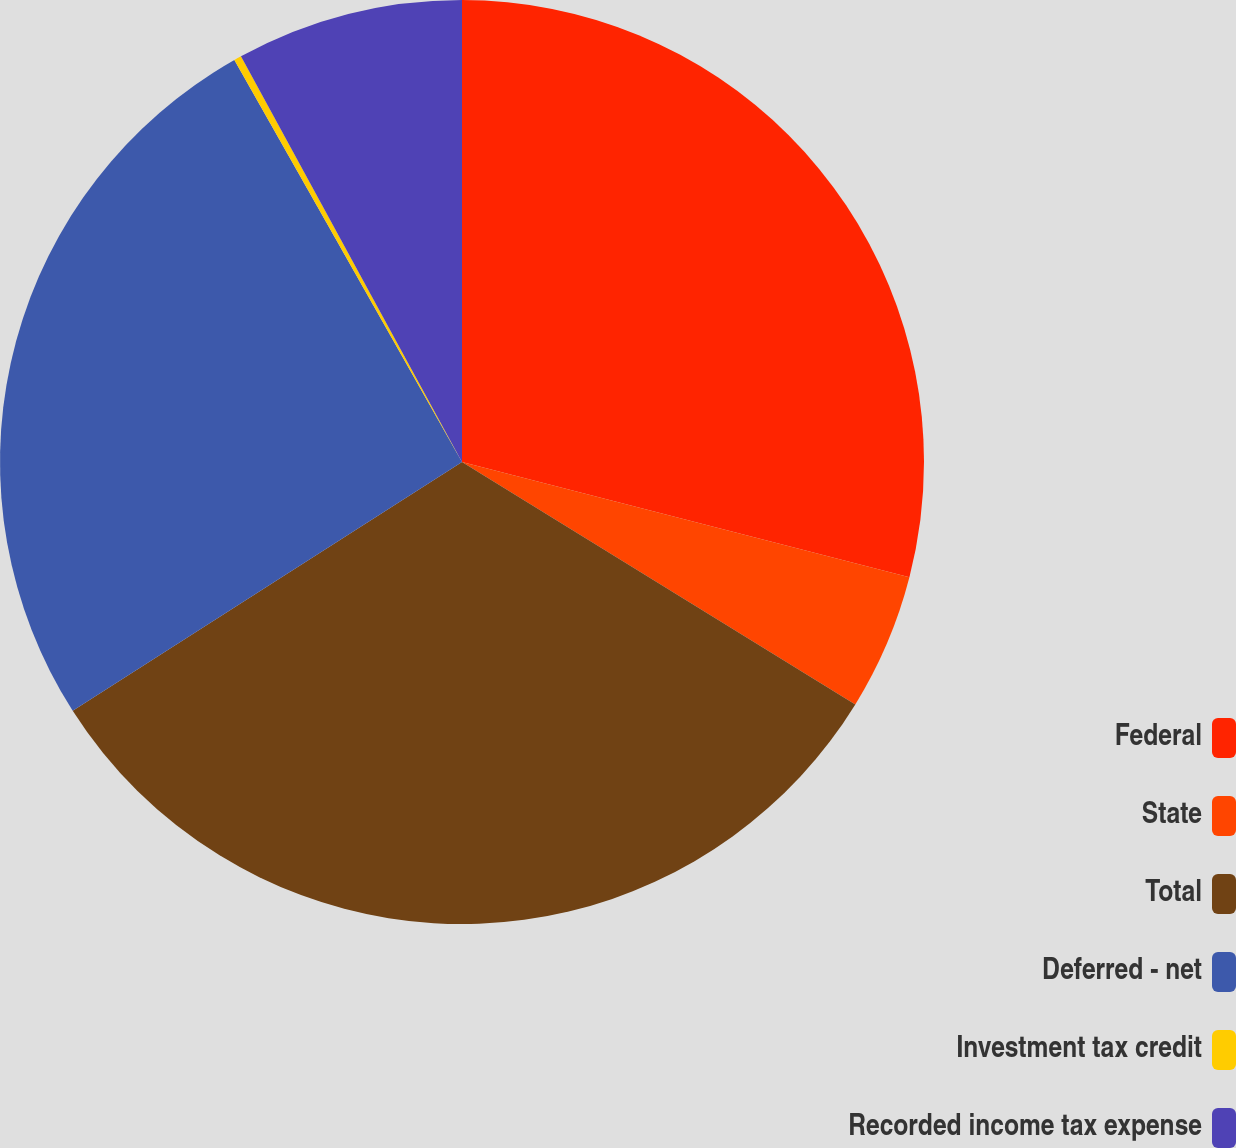<chart> <loc_0><loc_0><loc_500><loc_500><pie_chart><fcel>Federal<fcel>State<fcel>Total<fcel>Deferred - net<fcel>Investment tax credit<fcel>Recorded income tax expense<nl><fcel>29.01%<fcel>4.78%<fcel>32.16%<fcel>25.85%<fcel>0.26%<fcel>7.94%<nl></chart> 